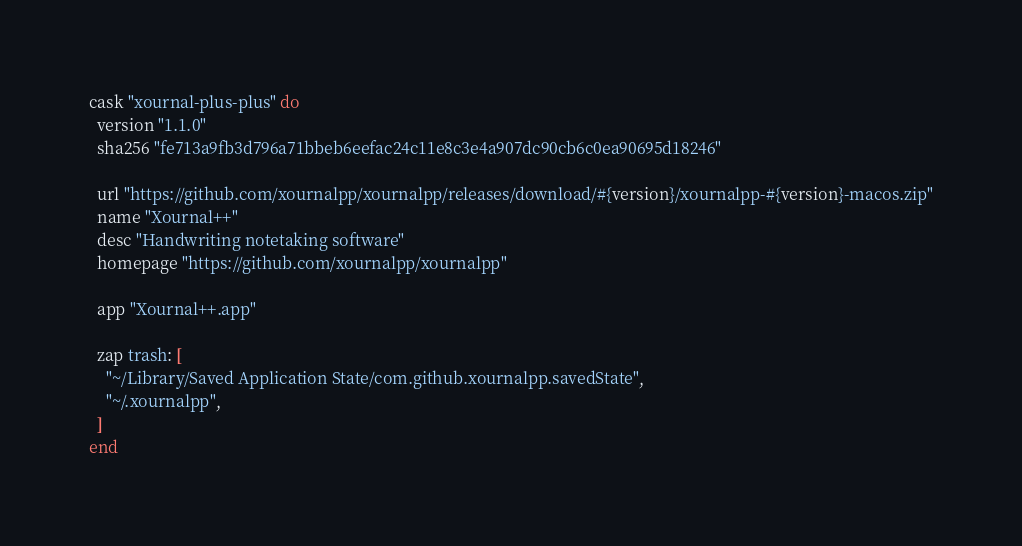<code> <loc_0><loc_0><loc_500><loc_500><_Ruby_>cask "xournal-plus-plus" do
  version "1.1.0"
  sha256 "fe713a9fb3d796a71bbeb6eefac24c11e8c3e4a907dc90cb6c0ea90695d18246"

  url "https://github.com/xournalpp/xournalpp/releases/download/#{version}/xournalpp-#{version}-macos.zip"
  name "Xournal++"
  desc "Handwriting notetaking software"
  homepage "https://github.com/xournalpp/xournalpp"

  app "Xournal++.app"

  zap trash: [
    "~/Library/Saved Application State/com.github.xournalpp.savedState",
    "~/.xournalpp",
  ]
end
</code> 